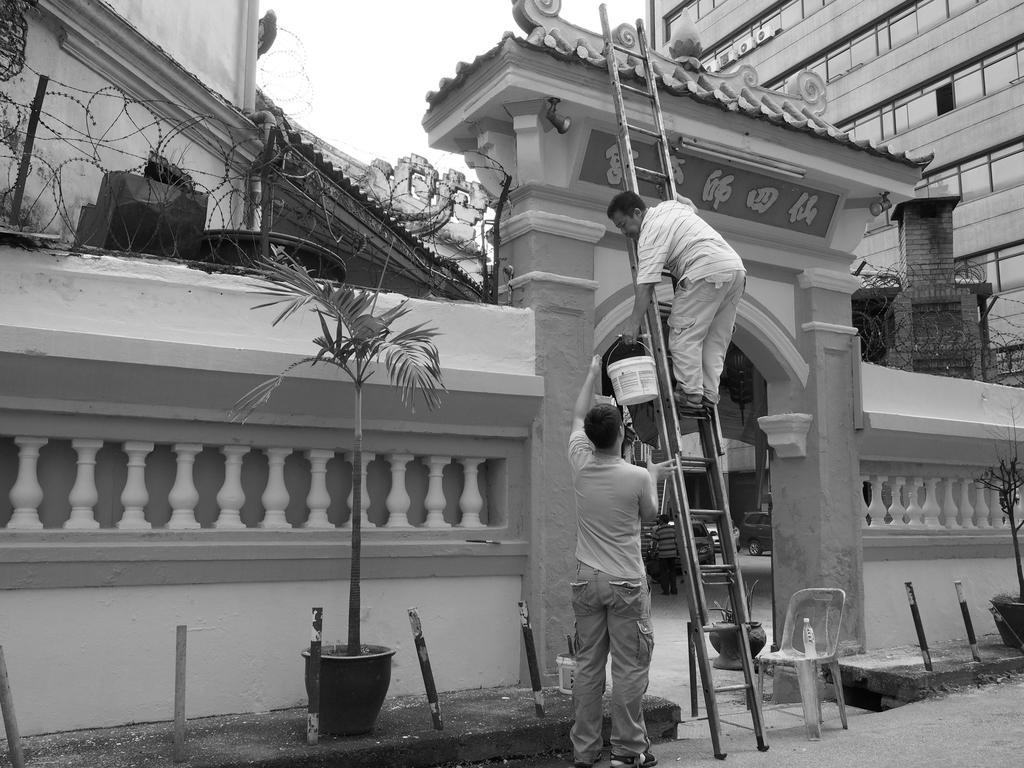Can you describe this image briefly? In this picture there is a person standing on the ladder and holding the bucket and there is a person standing. In the foreground there is an arch and there is text on the arch and there is a bottle on the chair and there are plants and rods. At the back there are buildings and there is fence on the wall. At the top there is sky. At the bottom there is a road and there are vehicles and there is a person walking behind the wall. 